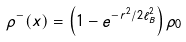Convert formula to latex. <formula><loc_0><loc_0><loc_500><loc_500>\rho ^ { - } ( x ) = \left ( 1 - e ^ { - r ^ { 2 } / 2 \ell _ { B } ^ { 2 } } \right ) \rho _ { 0 }</formula> 